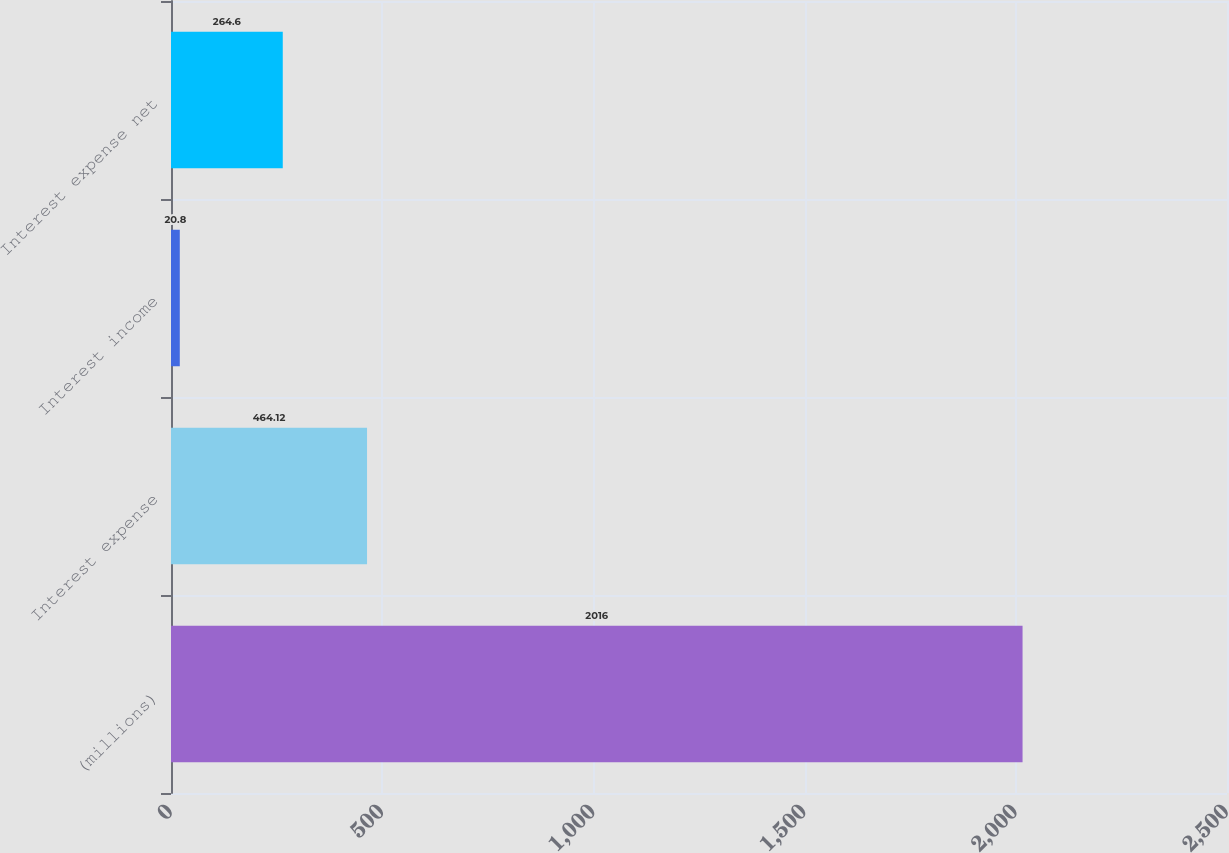<chart> <loc_0><loc_0><loc_500><loc_500><bar_chart><fcel>(millions)<fcel>Interest expense<fcel>Interest income<fcel>Interest expense net<nl><fcel>2016<fcel>464.12<fcel>20.8<fcel>264.6<nl></chart> 